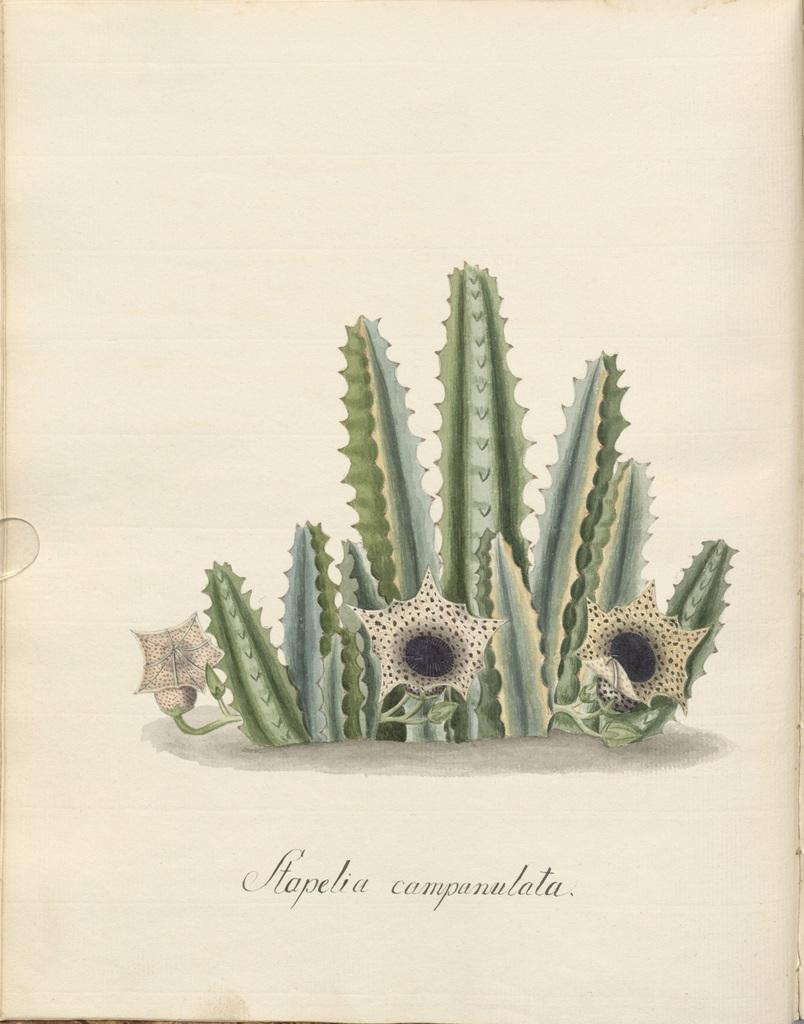What is depicted on the paper in the image? There is a cactus plant on the paper. Are there any additional features on the cactus plant? Yes, there are flowers on the cactus plant. What can be found at the bottom of the paper? There is text at the bottom of the paper. Can you see any thread being used to hold the grass in the image? There is no grass present in the image, and therefore no thread or any need to hold it. 